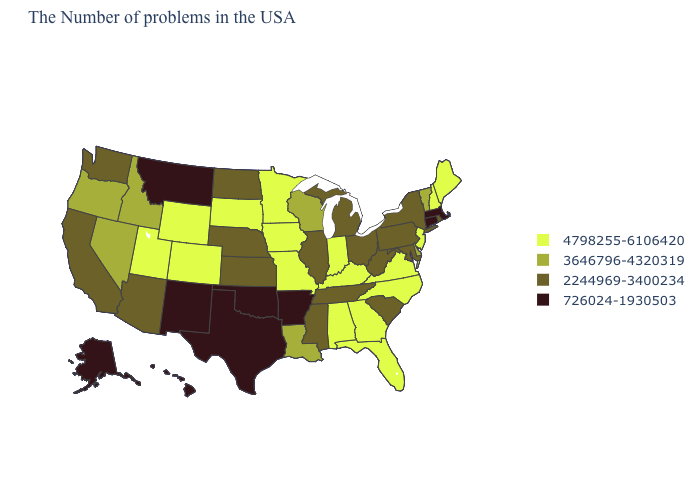How many symbols are there in the legend?
Quick response, please. 4. What is the lowest value in states that border Montana?
Short answer required. 2244969-3400234. What is the value of South Carolina?
Be succinct. 2244969-3400234. Which states have the lowest value in the USA?
Answer briefly. Massachusetts, Connecticut, Arkansas, Oklahoma, Texas, New Mexico, Montana, Alaska, Hawaii. Does Illinois have the lowest value in the USA?
Give a very brief answer. No. Does Oklahoma have the lowest value in the USA?
Concise answer only. Yes. Which states have the highest value in the USA?
Write a very short answer. Maine, New Hampshire, New Jersey, Virginia, North Carolina, Florida, Georgia, Kentucky, Indiana, Alabama, Missouri, Minnesota, Iowa, South Dakota, Wyoming, Colorado, Utah. Name the states that have a value in the range 2244969-3400234?
Keep it brief. Rhode Island, New York, Maryland, Pennsylvania, South Carolina, West Virginia, Ohio, Michigan, Tennessee, Illinois, Mississippi, Kansas, Nebraska, North Dakota, Arizona, California, Washington. What is the highest value in the Northeast ?
Short answer required. 4798255-6106420. Does the map have missing data?
Concise answer only. No. Is the legend a continuous bar?
Write a very short answer. No. What is the highest value in states that border Michigan?
Answer briefly. 4798255-6106420. Name the states that have a value in the range 726024-1930503?
Short answer required. Massachusetts, Connecticut, Arkansas, Oklahoma, Texas, New Mexico, Montana, Alaska, Hawaii. What is the highest value in the USA?
Concise answer only. 4798255-6106420. Which states have the lowest value in the USA?
Answer briefly. Massachusetts, Connecticut, Arkansas, Oklahoma, Texas, New Mexico, Montana, Alaska, Hawaii. 